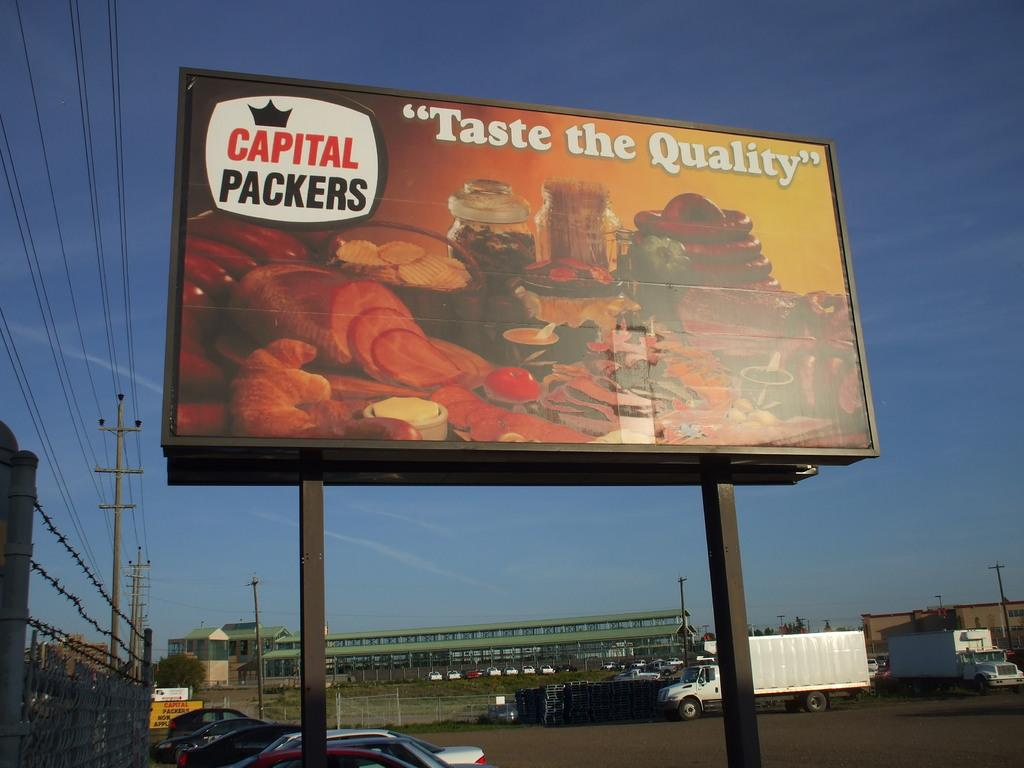Provide a one-sentence caption for the provided image. Billboard on display saying Taste the Quality by Capital  Packers. 